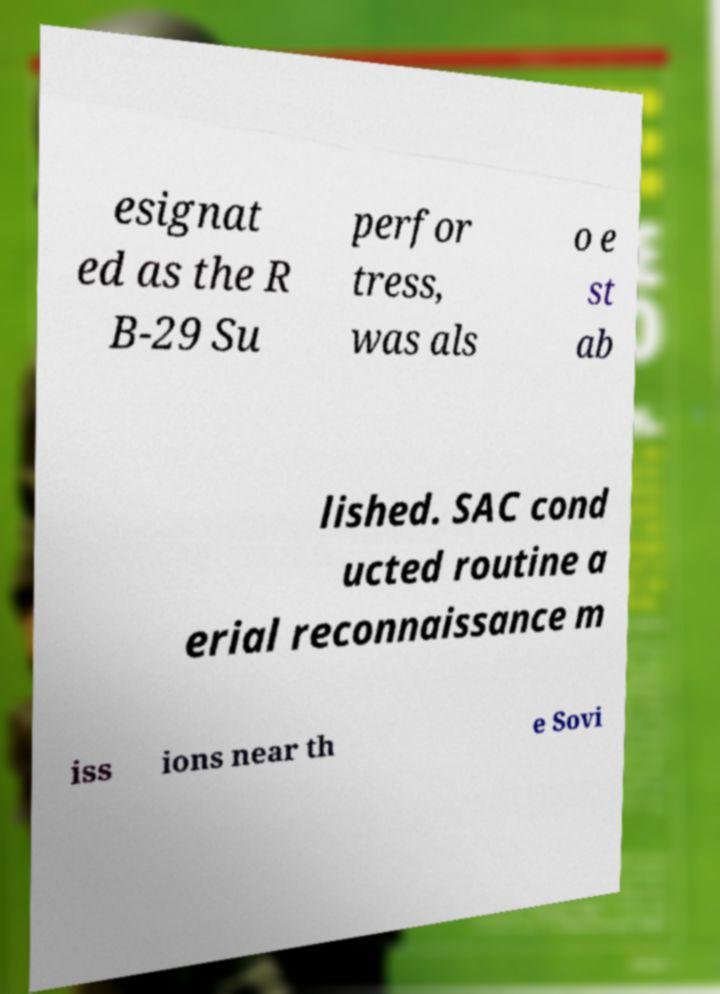What messages or text are displayed in this image? I need them in a readable, typed format. esignat ed as the R B-29 Su perfor tress, was als o e st ab lished. SAC cond ucted routine a erial reconnaissance m iss ions near th e Sovi 